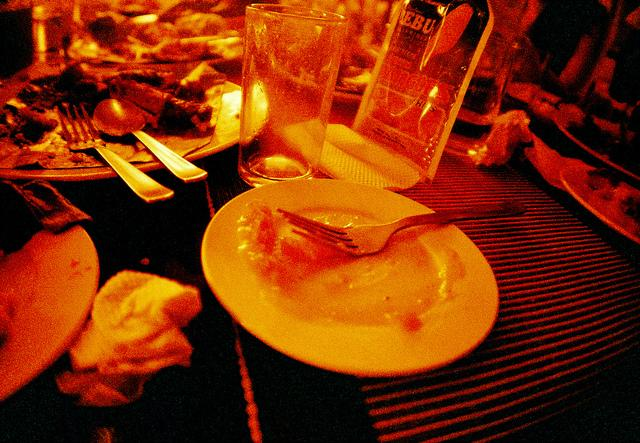Why would someone sit at this table? to eat 